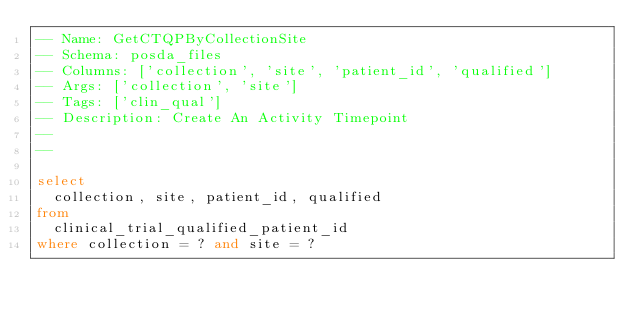<code> <loc_0><loc_0><loc_500><loc_500><_SQL_>-- Name: GetCTQPByCollectionSite
-- Schema: posda_files
-- Columns: ['collection', 'site', 'patient_id', 'qualified']
-- Args: ['collection', 'site']
-- Tags: ['clin_qual']
-- Description: Create An Activity Timepoint
-- 
-- 

select 
  collection, site, patient_id, qualified
from
  clinical_trial_qualified_patient_id
where collection = ? and site = ?</code> 